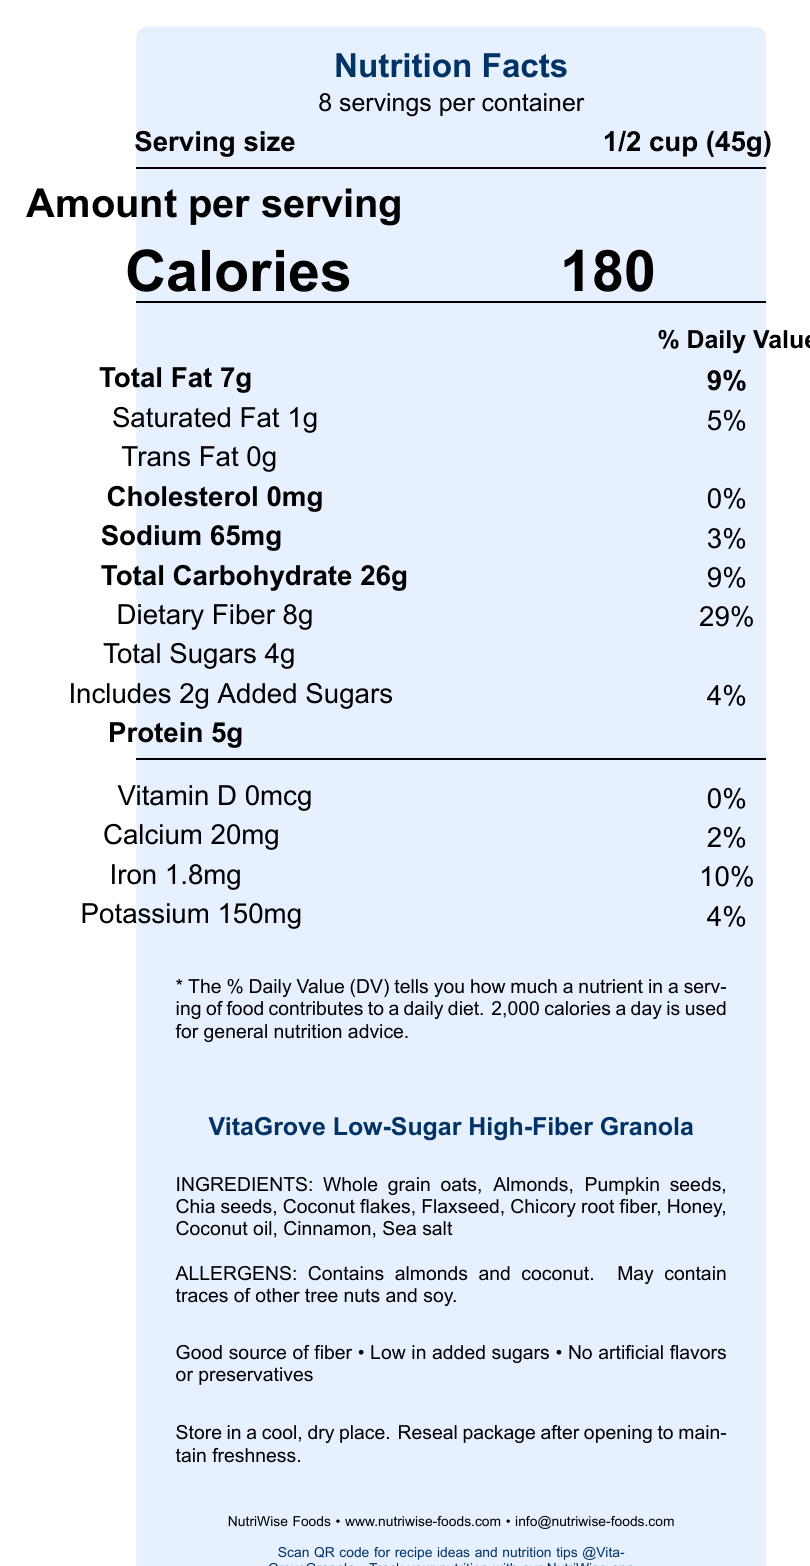what is the serving size of the VitaGrove Low-Sugar High-Fiber Granola? The serving size is clearly stated as "1/2 cup (45g)" in the nutrition facts section.
Answer: 1/2 cup (45g) how many calories are in one serving? The document lists "Calories 180" in the "Amount per serving" section.
Answer: 180 what is the percentage daily value of dietary fiber in one serving? The document states "Dietary Fiber 8g" and "29%" in the % daily value column.
Answer: 29% which two ingredients are allergens in this granola? The allergens section explicitly mentions "Contains almonds and coconut."
Answer: almonds and coconut is there any saturated fat in the granola? The document lists "Saturated Fat 1g" and "5%" under the total fat section.
Answer: Yes what is the total carbohydrate content per serving? The total carbohydrate content is listed as "26g" with a daily value of "9%."
Answer: 26g how much added sugar is in one serving of granola? The document states "Includes 2g Added Sugars" and "4%" in the sugars section.
Answer: 2g what company produces VitaGrove Low-Sugar High-Fiber Granola? The company information at the bottom mentions "NutriWise Foods."
Answer: NutriWise Foods which of the following is a health claim made by this product? A. High in protein B. Good source of iron C. Good source of fiber The document lists "Good source of fiber" as one of the health claims.
Answer: C. Good source of fiber how should the granola be stored to maintain freshness? A. In the refrigerator B. In the freezer C. In a cool, dry place The storage instructions clearly state, "Store in a cool, dry place."
Answer: C. In a cool, dry place does this granola contain any artificial flavors or preservatives? The document mentions in the health claims section "No artificial flavors or preservatives."
Answer: No does the granola have any protein content? The document lists "Protein 5g" under nutrition facts.
Answer: Yes summarize the main information provided in the document. The document extensively details the nutritional aspects and ingredients of the granola, showing its health benefits and how to store it. It also details the company's sustainability efforts and digital presence.
Answer: The document provides detailed nutrition facts about VitaGrove Low-Sugar High-Fiber Granola, including serving size, calorie count, and nutrient values. It lists the ingredients and allergen information, highlights several health claims, and provides storage instructions. The product is made by NutriWise Foods, and additional information is provided for digital engagement. what is the primary source of fiber in this granola? The document lists multiple ingredients that could contribute to fiber content, but it doesn't specify which is the primary source.
Answer: Not enough information how can consumers get additional recipe ideas and nutrition tips for this granola? The document mentions "Scan QR code for recipe ideas and nutrition tips" at the bottom.
Answer: By scanning the QR code what social media handle can be followed for more information about the granola? The document lists "@VitaGroveGranola" as the social media handle for the product.
Answer: @VitaGroveGranola what is the sodium content per serving? The document lists "Sodium 65mg" with a daily value of "3%" under nutrition facts.
Answer: 65mg which ingredient is not listed in the granola? A. Pumpkin seeds B. Almonds C. Raisins Raisins are not listed in the ingredients section; however, pumpkin seeds and almonds are.
Answer: C. Raisins 